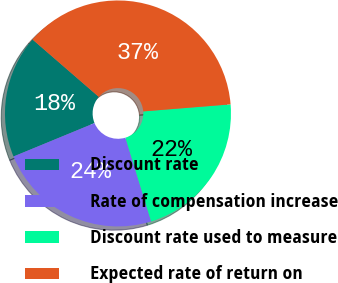Convert chart to OTSL. <chart><loc_0><loc_0><loc_500><loc_500><pie_chart><fcel>Discount rate<fcel>Rate of compensation increase<fcel>Discount rate used to measure<fcel>Expected rate of return on<nl><fcel>17.58%<fcel>23.52%<fcel>21.54%<fcel>37.36%<nl></chart> 